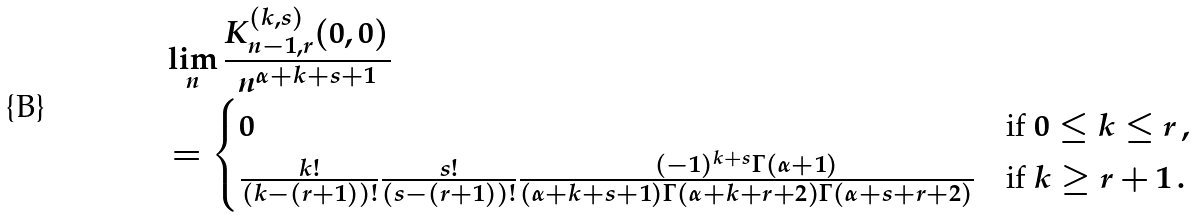Convert formula to latex. <formula><loc_0><loc_0><loc_500><loc_500>& \lim _ { n } \frac { K _ { n - 1 , r } ^ { ( k , s ) } ( 0 , 0 ) } { n ^ { \alpha + k + s + 1 } } \\ & = \begin{cases} 0 & \text {if $0 \leq k \leq r$} \, , \\ \frac { k ! } { ( k - ( r + 1 ) ) ! } \frac { s ! } { ( s - ( r + 1 ) ) ! } \frac { ( - 1 ) ^ { k + s } \Gamma ( \alpha + 1 ) } { ( \alpha + k + s + 1 ) \Gamma ( \alpha + k + r + 2 ) \Gamma ( \alpha + s + r + 2 ) } & \text {if $k \geq r+1$} \, . \end{cases}</formula> 